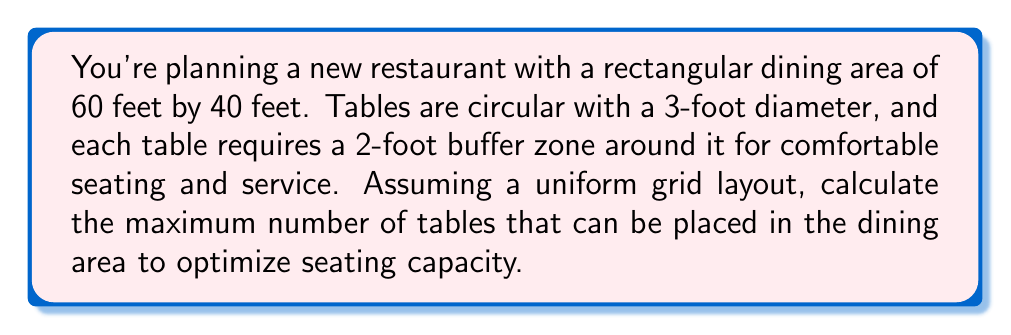Could you help me with this problem? Let's approach this step-by-step:

1) First, we need to calculate the effective space each table occupies, including its buffer zone:
   Effective diameter = Table diameter + (2 × Buffer zone)
   $$ d_{effective} = 3 + (2 × 2) = 7 \text{ feet} $$

2) Now, we need to determine how many tables can fit along each dimension:

   For the length (60 feet):
   $$ n_{length} = \left\lfloor\frac{60}{7}\right\rfloor = 8 \text{ tables} $$

   For the width (40 feet):
   $$ n_{width} = \left\lfloor\frac{40}{7}\right\rfloor = 5 \text{ tables} $$

   Where $\lfloor \cdot \rfloor$ denotes the floor function (rounding down to the nearest integer).

3) The total number of tables is the product of these two values:
   $$ n_{total} = n_{length} × n_{width} = 8 × 5 = 40 \text{ tables} $$

4) To visualize this arrangement:

[asy]
size(200,133.33);
for(int i=0; i<9; ++i)
  draw((i*25,0)--(i*25,100),gray);
for(int j=0; j<6; ++j)
  draw((0,j*25)--(200,j*25),gray);
for(int i=0; i<8; ++i)
  for(int j=0; j<5; ++j)
    draw(circle((i*25+12.5,j*25+12.5),12.5));
[/asy]

This layout ensures optimal use of space while maintaining the required buffer zones for comfortable seating and service.
Answer: 40 tables 